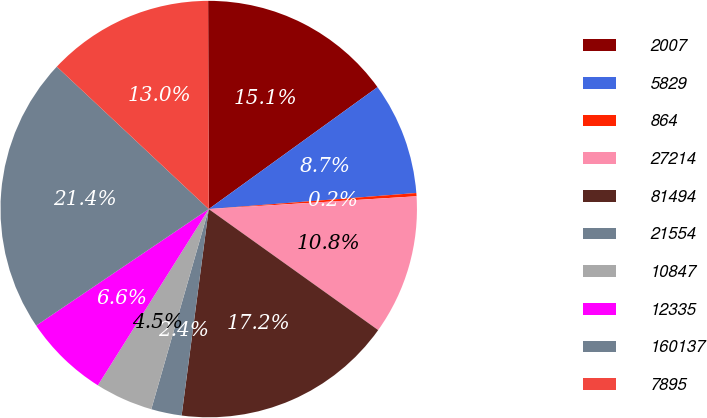Convert chart to OTSL. <chart><loc_0><loc_0><loc_500><loc_500><pie_chart><fcel>2007<fcel>5829<fcel>864<fcel>27214<fcel>81494<fcel>21554<fcel>10847<fcel>12335<fcel>160137<fcel>7895<nl><fcel>15.09%<fcel>8.73%<fcel>0.25%<fcel>10.85%<fcel>17.21%<fcel>2.37%<fcel>4.49%<fcel>6.61%<fcel>21.44%<fcel>12.97%<nl></chart> 